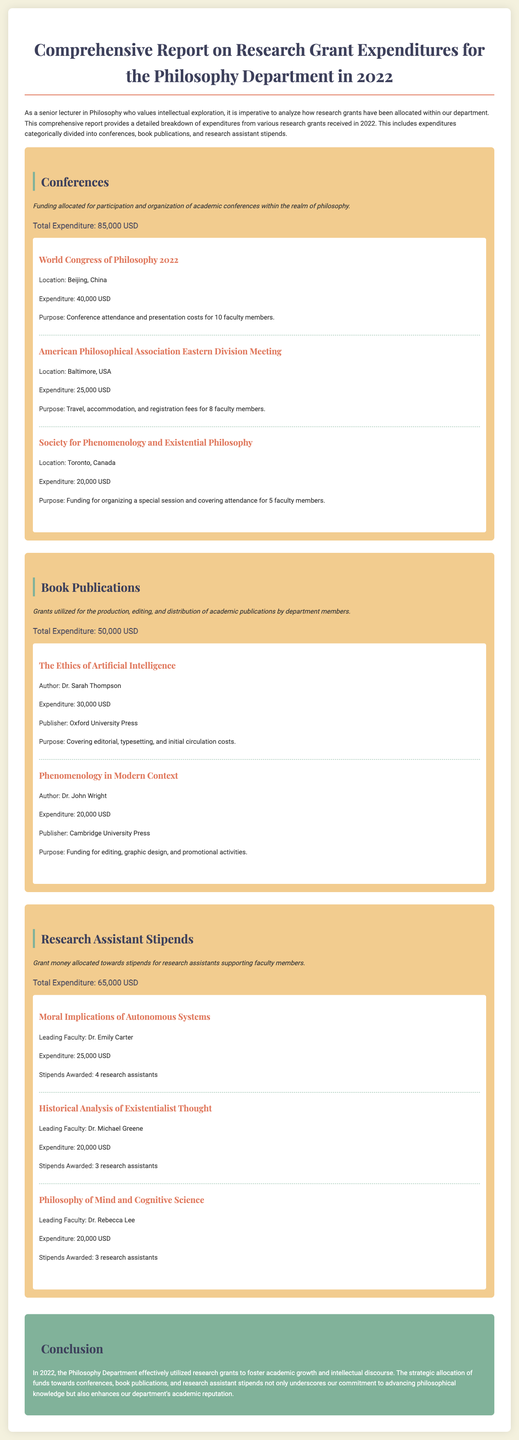What is the total expenditure for conferences? The total expenditure for conferences is clearly stated in the document under the conference category.
Answer: 85,000 USD Who authored "The Ethics of Artificial Intelligence"? The author of the book "The Ethics of Artificial Intelligence" is mentioned in the book publication section.
Answer: Dr. Sarah Thompson How many research assistants were awarded stipends for "Historical Analysis of Existentialist Thought"? The number of research assistants awarded stipends for this project is detailed in the research assistant stipends section.
Answer: 3 research assistants What was the expenditure for the World Congress of Philosophy 2022? The expenditure for this specific conference is provided in the details of the conference category.
Answer: 40,000 USD Which publisher released "Phenomenology in Modern Context"? The publisher for this book publication is indicated in the document.
Answer: Cambridge University Press What is the purpose of the funding for the Society for Phenomenology and Existential Philosophy? The purpose of the funding is explained in the document under the specific conference expenditure details.
Answer: Organizing a special session and covering attendance for 5 faculty members How much was allocated for research assistant stipends in total? The total allocation for research assistant stipends is summarized in the research assistant stipends category.
Answer: 65,000 USD 